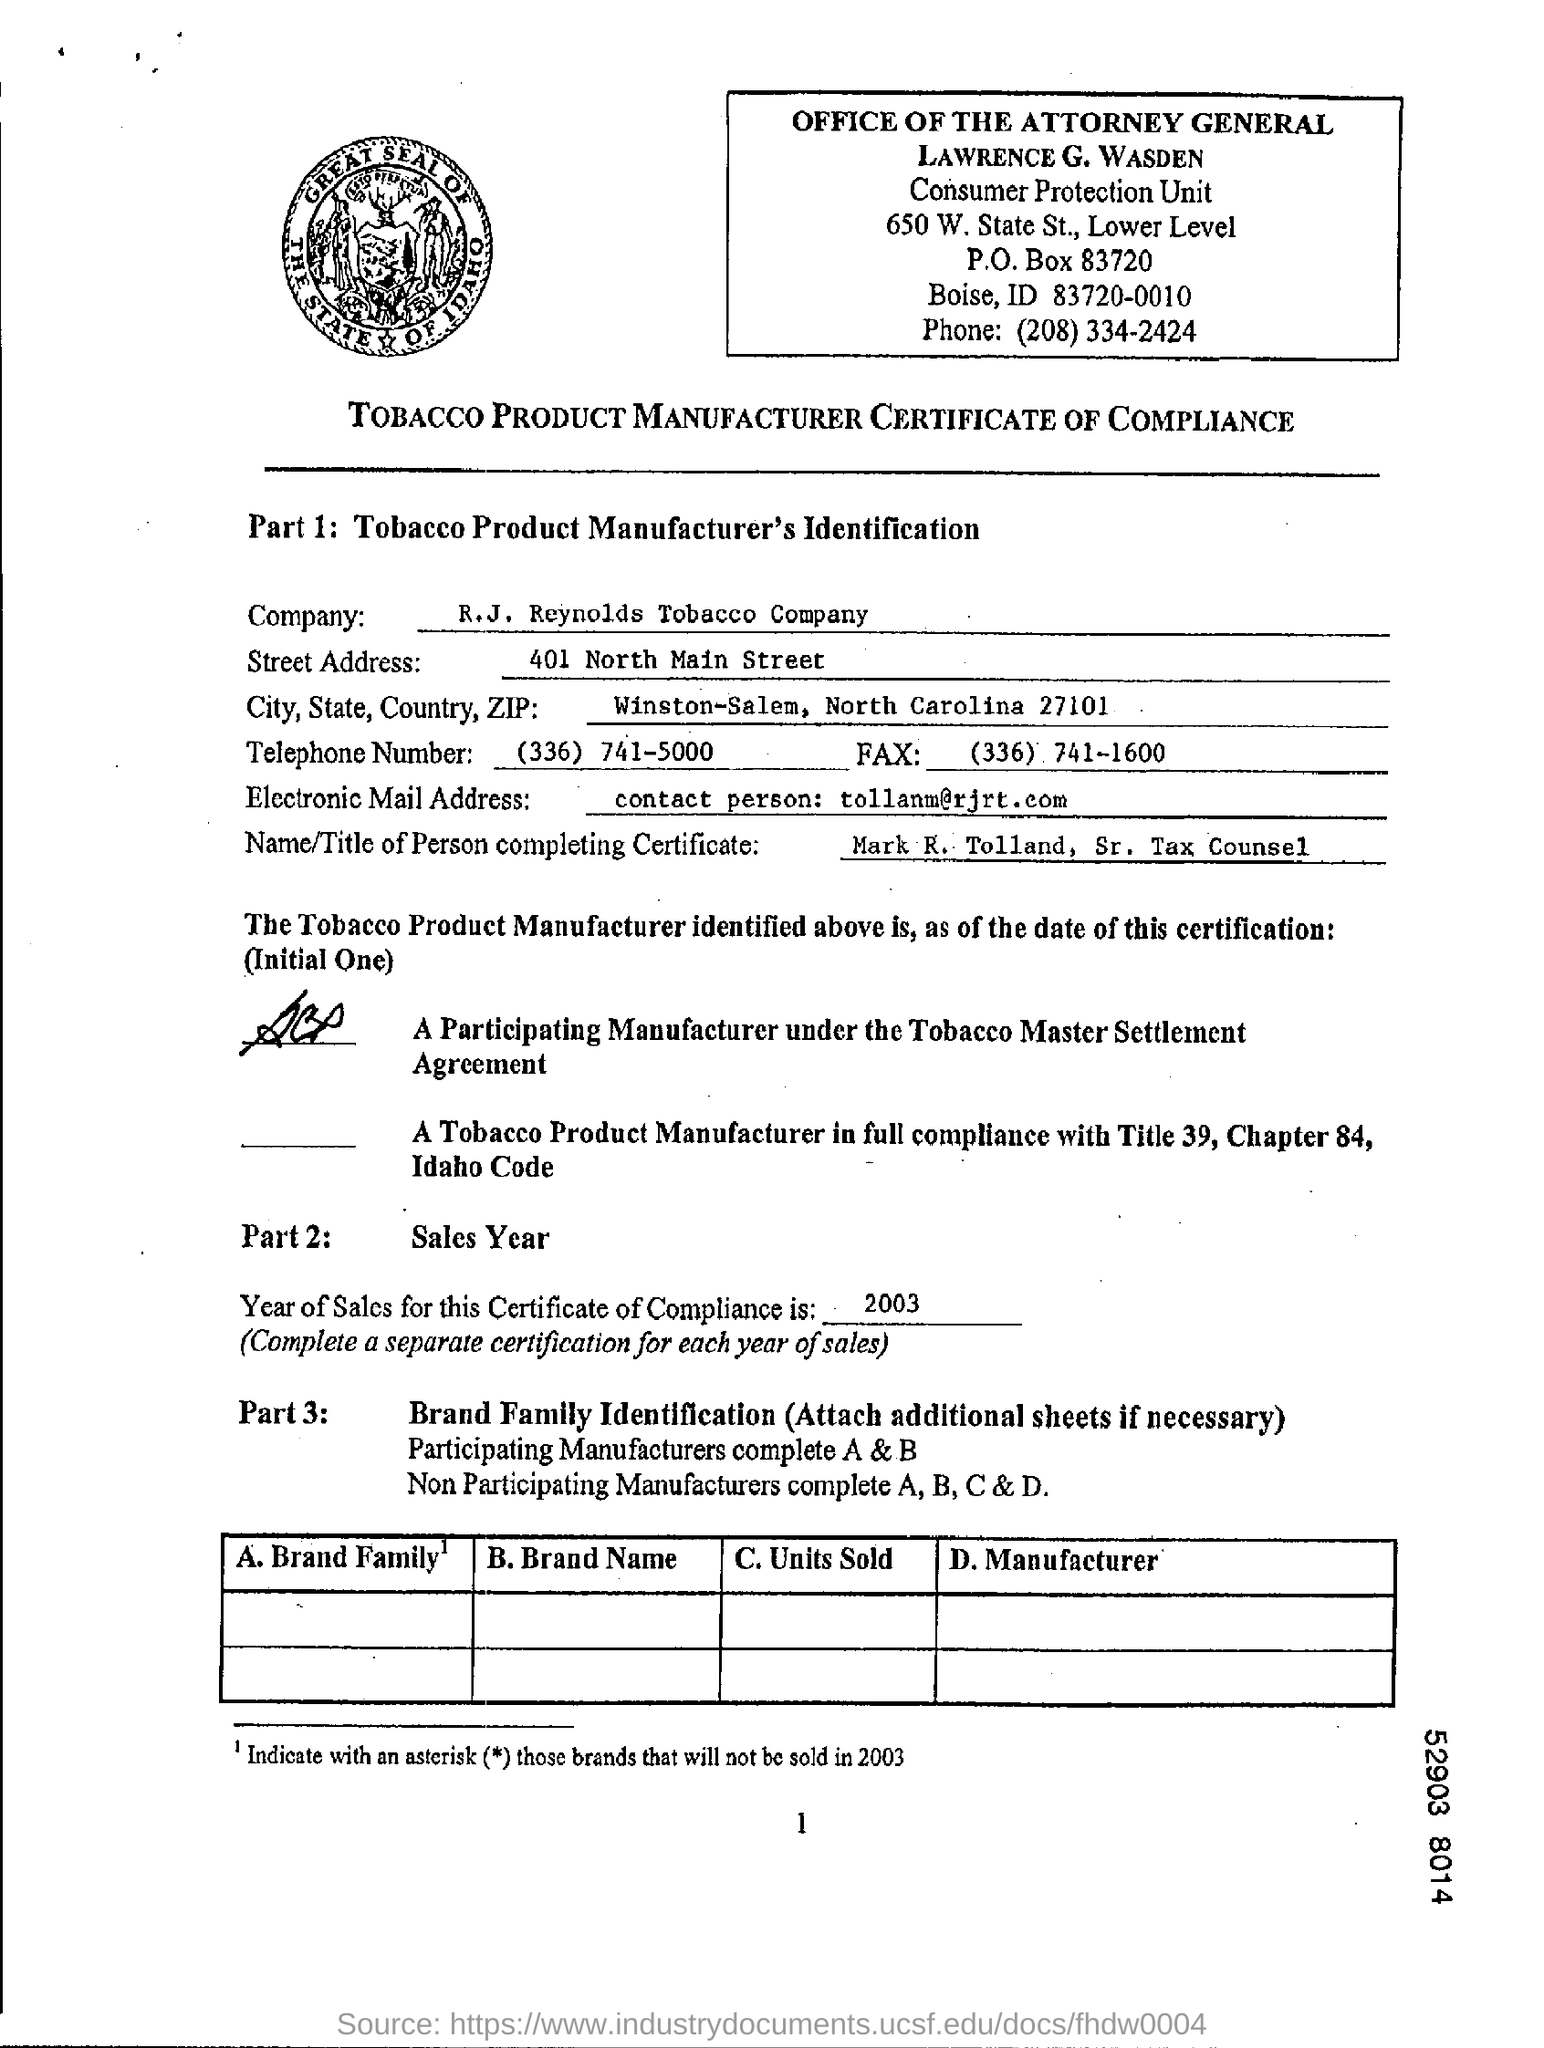Outline some significant characteristics in this image. The electronic mail address field contains the written contact person, whose name is "Tolland M." and their email address is "[tollanm@rjrt.com](mailto:tollanm@rjrt.com)". The information written in the Street Address Field is 401 North Main Street. The R.J. Reynolds Tobacco Company is a company name. The telephone number is (336) 741-5000. The fax number is (336) 741-1600. 